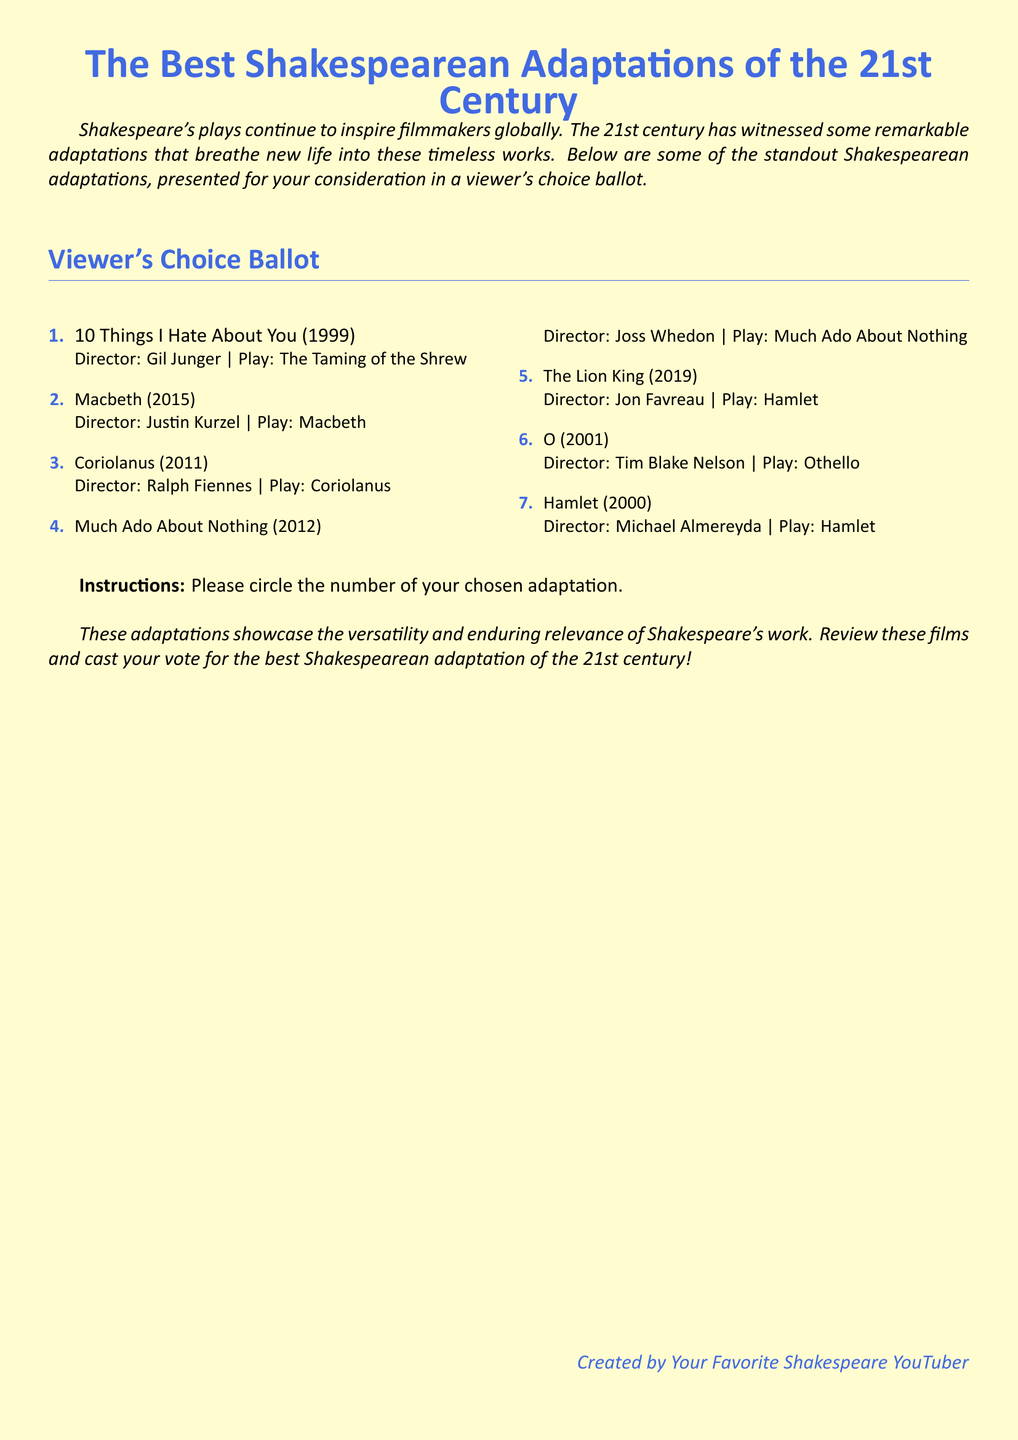What is the title of the document? The title is presented at the top center of the document and clearly states the topic of the ballot.
Answer: The Best Shakespearean Adaptations of the 21st Century How many adaptations are listed? The document includes a numbered list of adaptations, which can be counted directly.
Answer: 7 Who directed "Macbeth"? The director's name is listed alongside the adaptation's title and the play it is based on.
Answer: Justin Kurzel Which play is "10 Things I Hate About You" based on? The play is specified in the description of the adaptation immediately following its title.
Answer: The Taming of the Shrew What year was "Much Ado About Nothing" released? The release year is provided directly after the adaptation's title in the document.
Answer: 2012 Which adaptation is based on "Hamlet" and released in 2000? The adaptation is clearly identified in the list with its corresponding release year.
Answer: Hamlet How is participation in the ballot instructed? The instruction details are clearly mentioned in a distinct section towards the bottom of the document.
Answer: Circle the number of your chosen adaptation What color is used for the heading? The color used for headings is specified in the formatting section of the document.
Answer: Shakespearean blue 